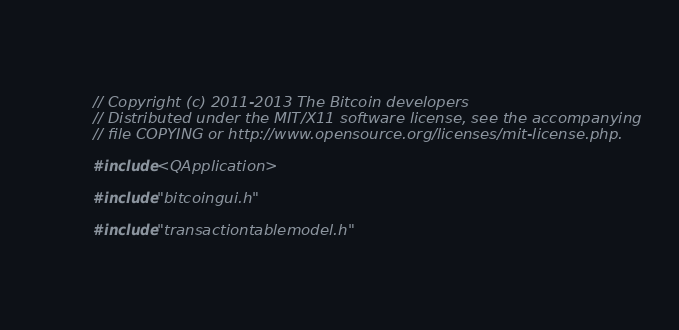<code> <loc_0><loc_0><loc_500><loc_500><_C++_>// Copyright (c) 2011-2013 The Bitcoin developers
// Distributed under the MIT/X11 software license, see the accompanying
// file COPYING or http://www.opensource.org/licenses/mit-license.php.

#include <QApplication>

#include "bitcoingui.h"

#include "transactiontablemodel.h"</code> 